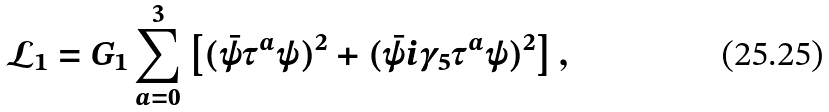Convert formula to latex. <formula><loc_0><loc_0><loc_500><loc_500>\mathcal { L } _ { 1 } = G _ { 1 } \sum _ { a = 0 } ^ { 3 } \left [ ( \bar { \psi } \tau ^ { a } \psi ) ^ { 2 } + ( \bar { \psi } i \gamma _ { 5 } \tau ^ { a } \psi ) ^ { 2 } \right ] ,</formula> 